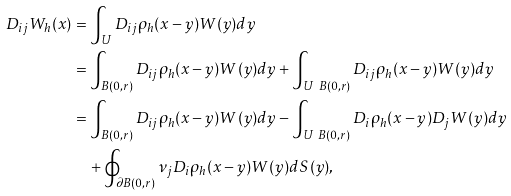Convert formula to latex. <formula><loc_0><loc_0><loc_500><loc_500>D _ { i j } W _ { h } ( x ) & = \int _ { U } D _ { i j } \rho _ { h } ( x - y ) W ( y ) d y \\ & = \int _ { B ( 0 , r ) } D _ { i j } \rho _ { h } ( x - y ) W ( y ) d y + \int _ { U \ B ( 0 , r ) } D _ { i j } \rho _ { h } ( x - y ) W ( y ) d y \\ & = \int _ { B ( 0 , r ) } D _ { i j } \rho _ { h } ( x - y ) W ( y ) d y - \int _ { U \ B ( 0 , r ) } D _ { i } \rho _ { h } ( x - y ) D _ { j } W ( y ) d y \\ & \quad + \oint _ { \partial B ( 0 , r ) } \nu _ { j } D _ { i } \rho _ { h } ( x - y ) W ( y ) d S ( y ) ,</formula> 